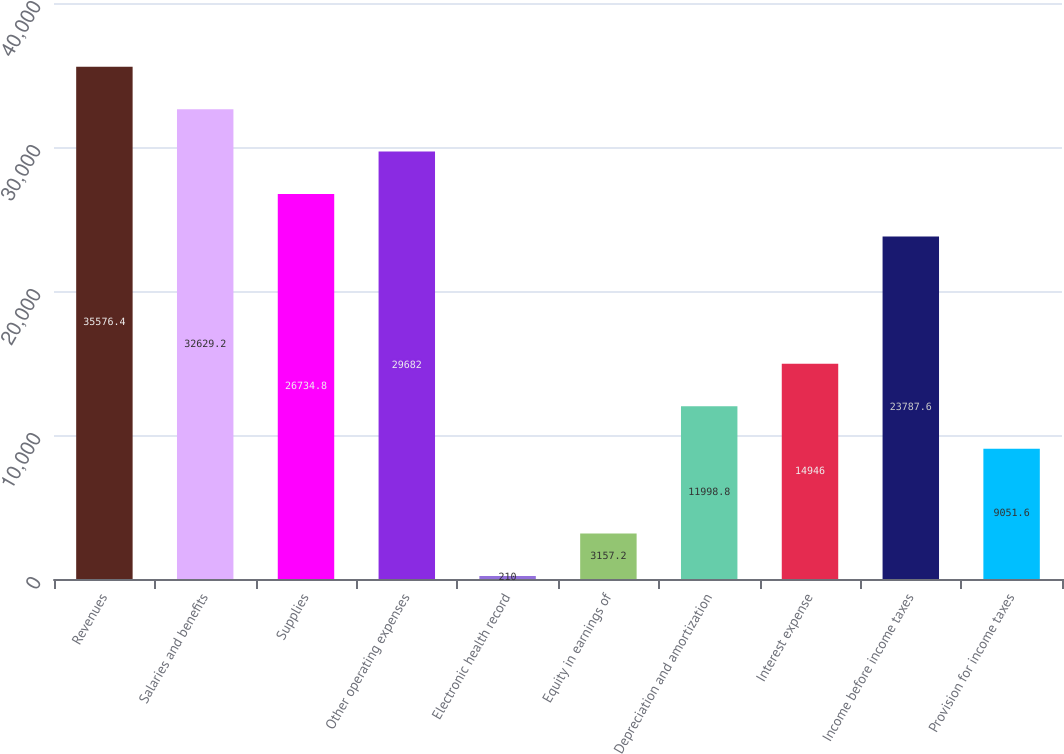<chart> <loc_0><loc_0><loc_500><loc_500><bar_chart><fcel>Revenues<fcel>Salaries and benefits<fcel>Supplies<fcel>Other operating expenses<fcel>Electronic health record<fcel>Equity in earnings of<fcel>Depreciation and amortization<fcel>Interest expense<fcel>Income before income taxes<fcel>Provision for income taxes<nl><fcel>35576.4<fcel>32629.2<fcel>26734.8<fcel>29682<fcel>210<fcel>3157.2<fcel>11998.8<fcel>14946<fcel>23787.6<fcel>9051.6<nl></chart> 